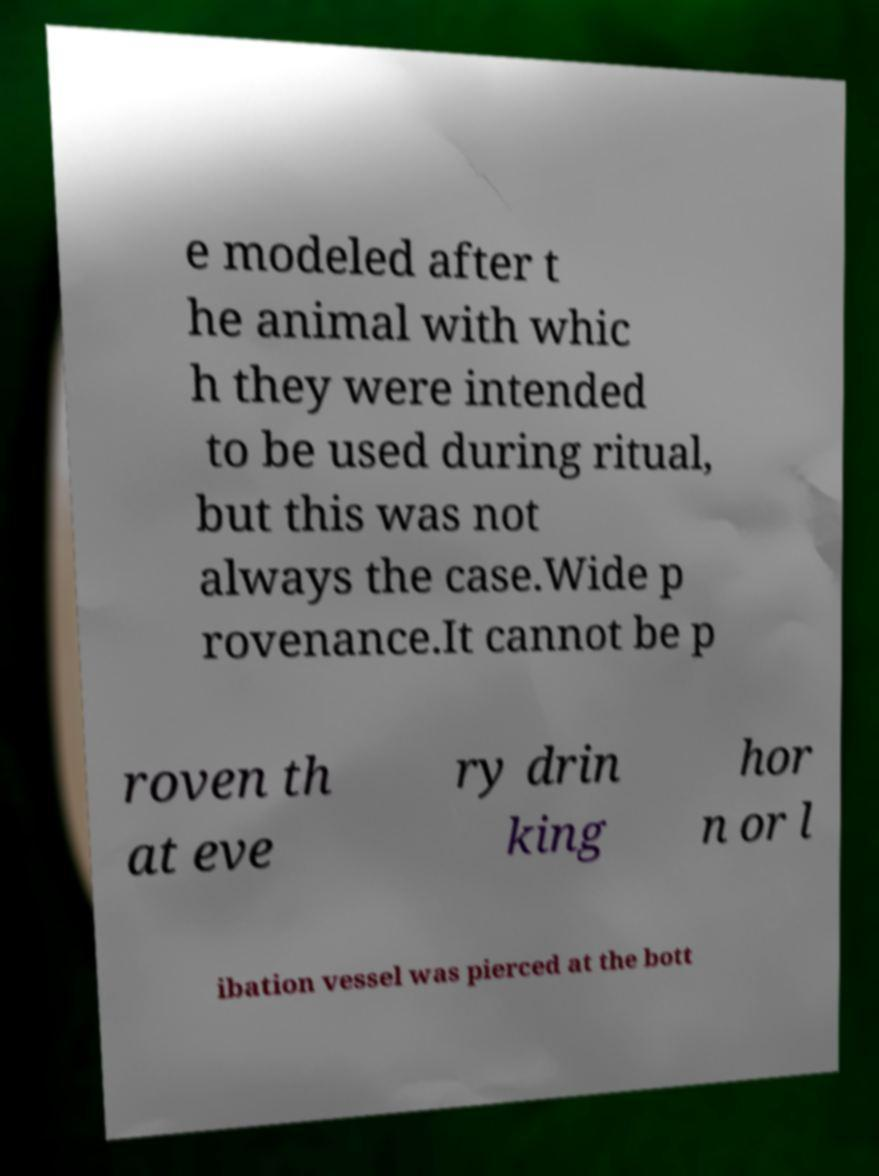Can you read and provide the text displayed in the image?This photo seems to have some interesting text. Can you extract and type it out for me? e modeled after t he animal with whic h they were intended to be used during ritual, but this was not always the case.Wide p rovenance.It cannot be p roven th at eve ry drin king hor n or l ibation vessel was pierced at the bott 